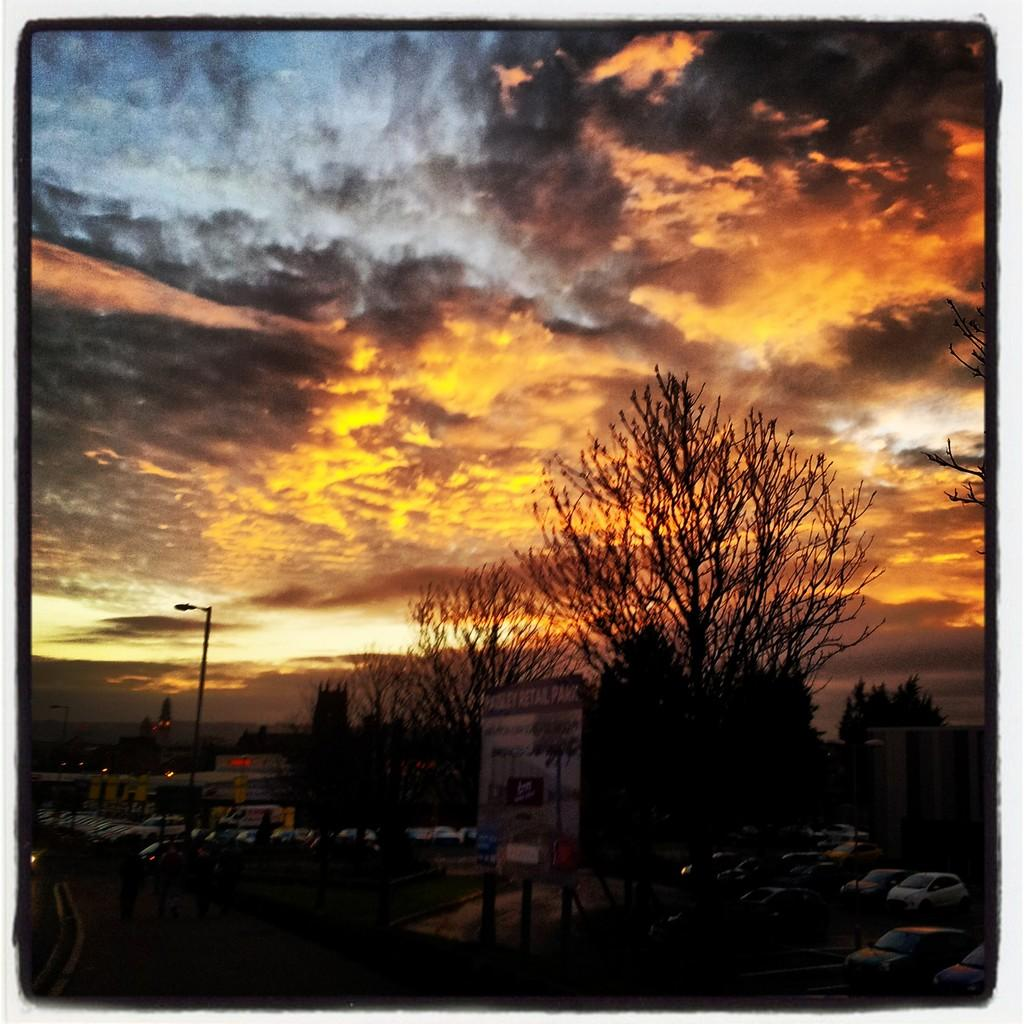What type of natural elements can be seen in the image? There are trees in the image. What type of man-made structures are present in the image? There are buildings in the image. What type of vehicles are parked in the image? There are cars parked in the image. What type of signage is present in the image? There is a board with text in the image. What type of lighting is present in the image? There is a pole light on the left side of the image. What part of the natural environment is visible in the image? The sky is visible in the image. What type of shoes can be seen hanging from the pole light in the image? There are no shoes present in the image, and therefore none can be seen hanging from the pole light. What time of day is it in the image, given the presence of the afternoon sun? The presence of the sky in the image does not indicate a specific time of day, and there is no mention of the sun. 